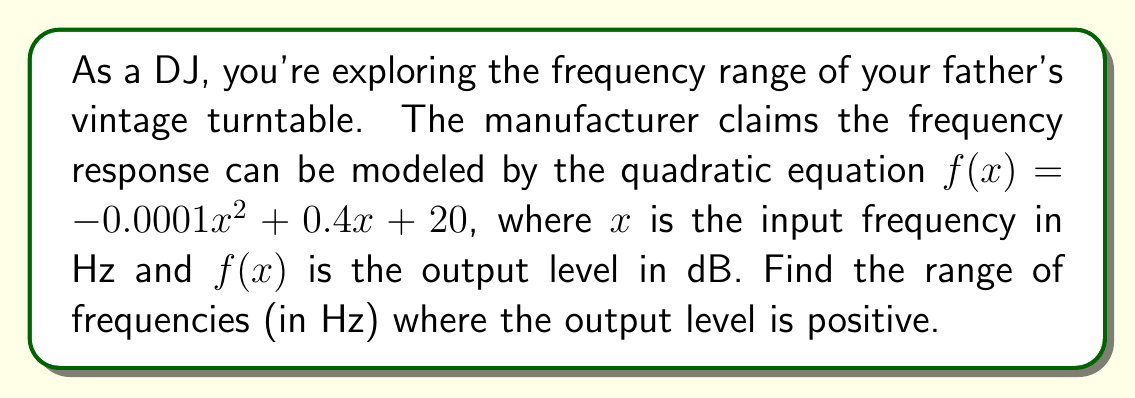Teach me how to tackle this problem. To solve this problem, we need to find the roots of the quadratic equation when $f(x) = 0$. This will give us the points where the output level crosses from positive to negative.

1) First, let's set up the equation:
   $-0.0001x^2 + 0.4x + 20 = 0$

2) This is in the standard form of a quadratic equation: $ax^2 + bx + c = 0$
   Where $a = -0.0001$, $b = 0.4$, and $c = 20$

3) We can solve this using the quadratic formula: $x = \frac{-b \pm \sqrt{b^2 - 4ac}}{2a}$

4) Let's substitute our values:
   $x = \frac{-0.4 \pm \sqrt{0.4^2 - 4(-0.0001)(20)}}{2(-0.0001)}$

5) Simplify under the square root:
   $x = \frac{-0.4 \pm \sqrt{0.16 + 0.008}}{-0.0002} = \frac{-0.4 \pm \sqrt{0.168}}{-0.0002}$

6) Simplify further:
   $x = \frac{-0.4 \pm 0.41}{-0.0002}$

7) This gives us two solutions:
   $x_1 = \frac{-0.4 + 0.41}{-0.0002} = -50$ Hz
   $x_2 = \frac{-0.4 - 0.41}{-0.0002} = 4050$ Hz

8) Since frequency can't be negative, we discard the negative solution.

Therefore, the output level is positive between 0 Hz and 4050 Hz.
Answer: The range of frequencies where the output level is positive is 0 Hz to 4050 Hz. 